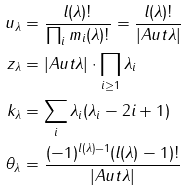<formula> <loc_0><loc_0><loc_500><loc_500>u _ { \lambda } & = \frac { l ( \lambda ) ! } { \prod _ { i } m _ { i } ( \lambda ) ! } = \frac { l ( \lambda ) ! } { | A u t \lambda | } \\ z _ { \lambda } & = | A u t \lambda | \cdot \prod _ { i \geq 1 } \lambda _ { i } \\ k _ { \lambda } & = \sum _ { i } \lambda _ { i } ( \lambda _ { i } - 2 i + 1 ) \\ \theta _ { \lambda } & = \frac { ( - 1 ) ^ { l ( \lambda ) - 1 } ( l ( \lambda ) - 1 ) ! } { | A u t \lambda | }</formula> 